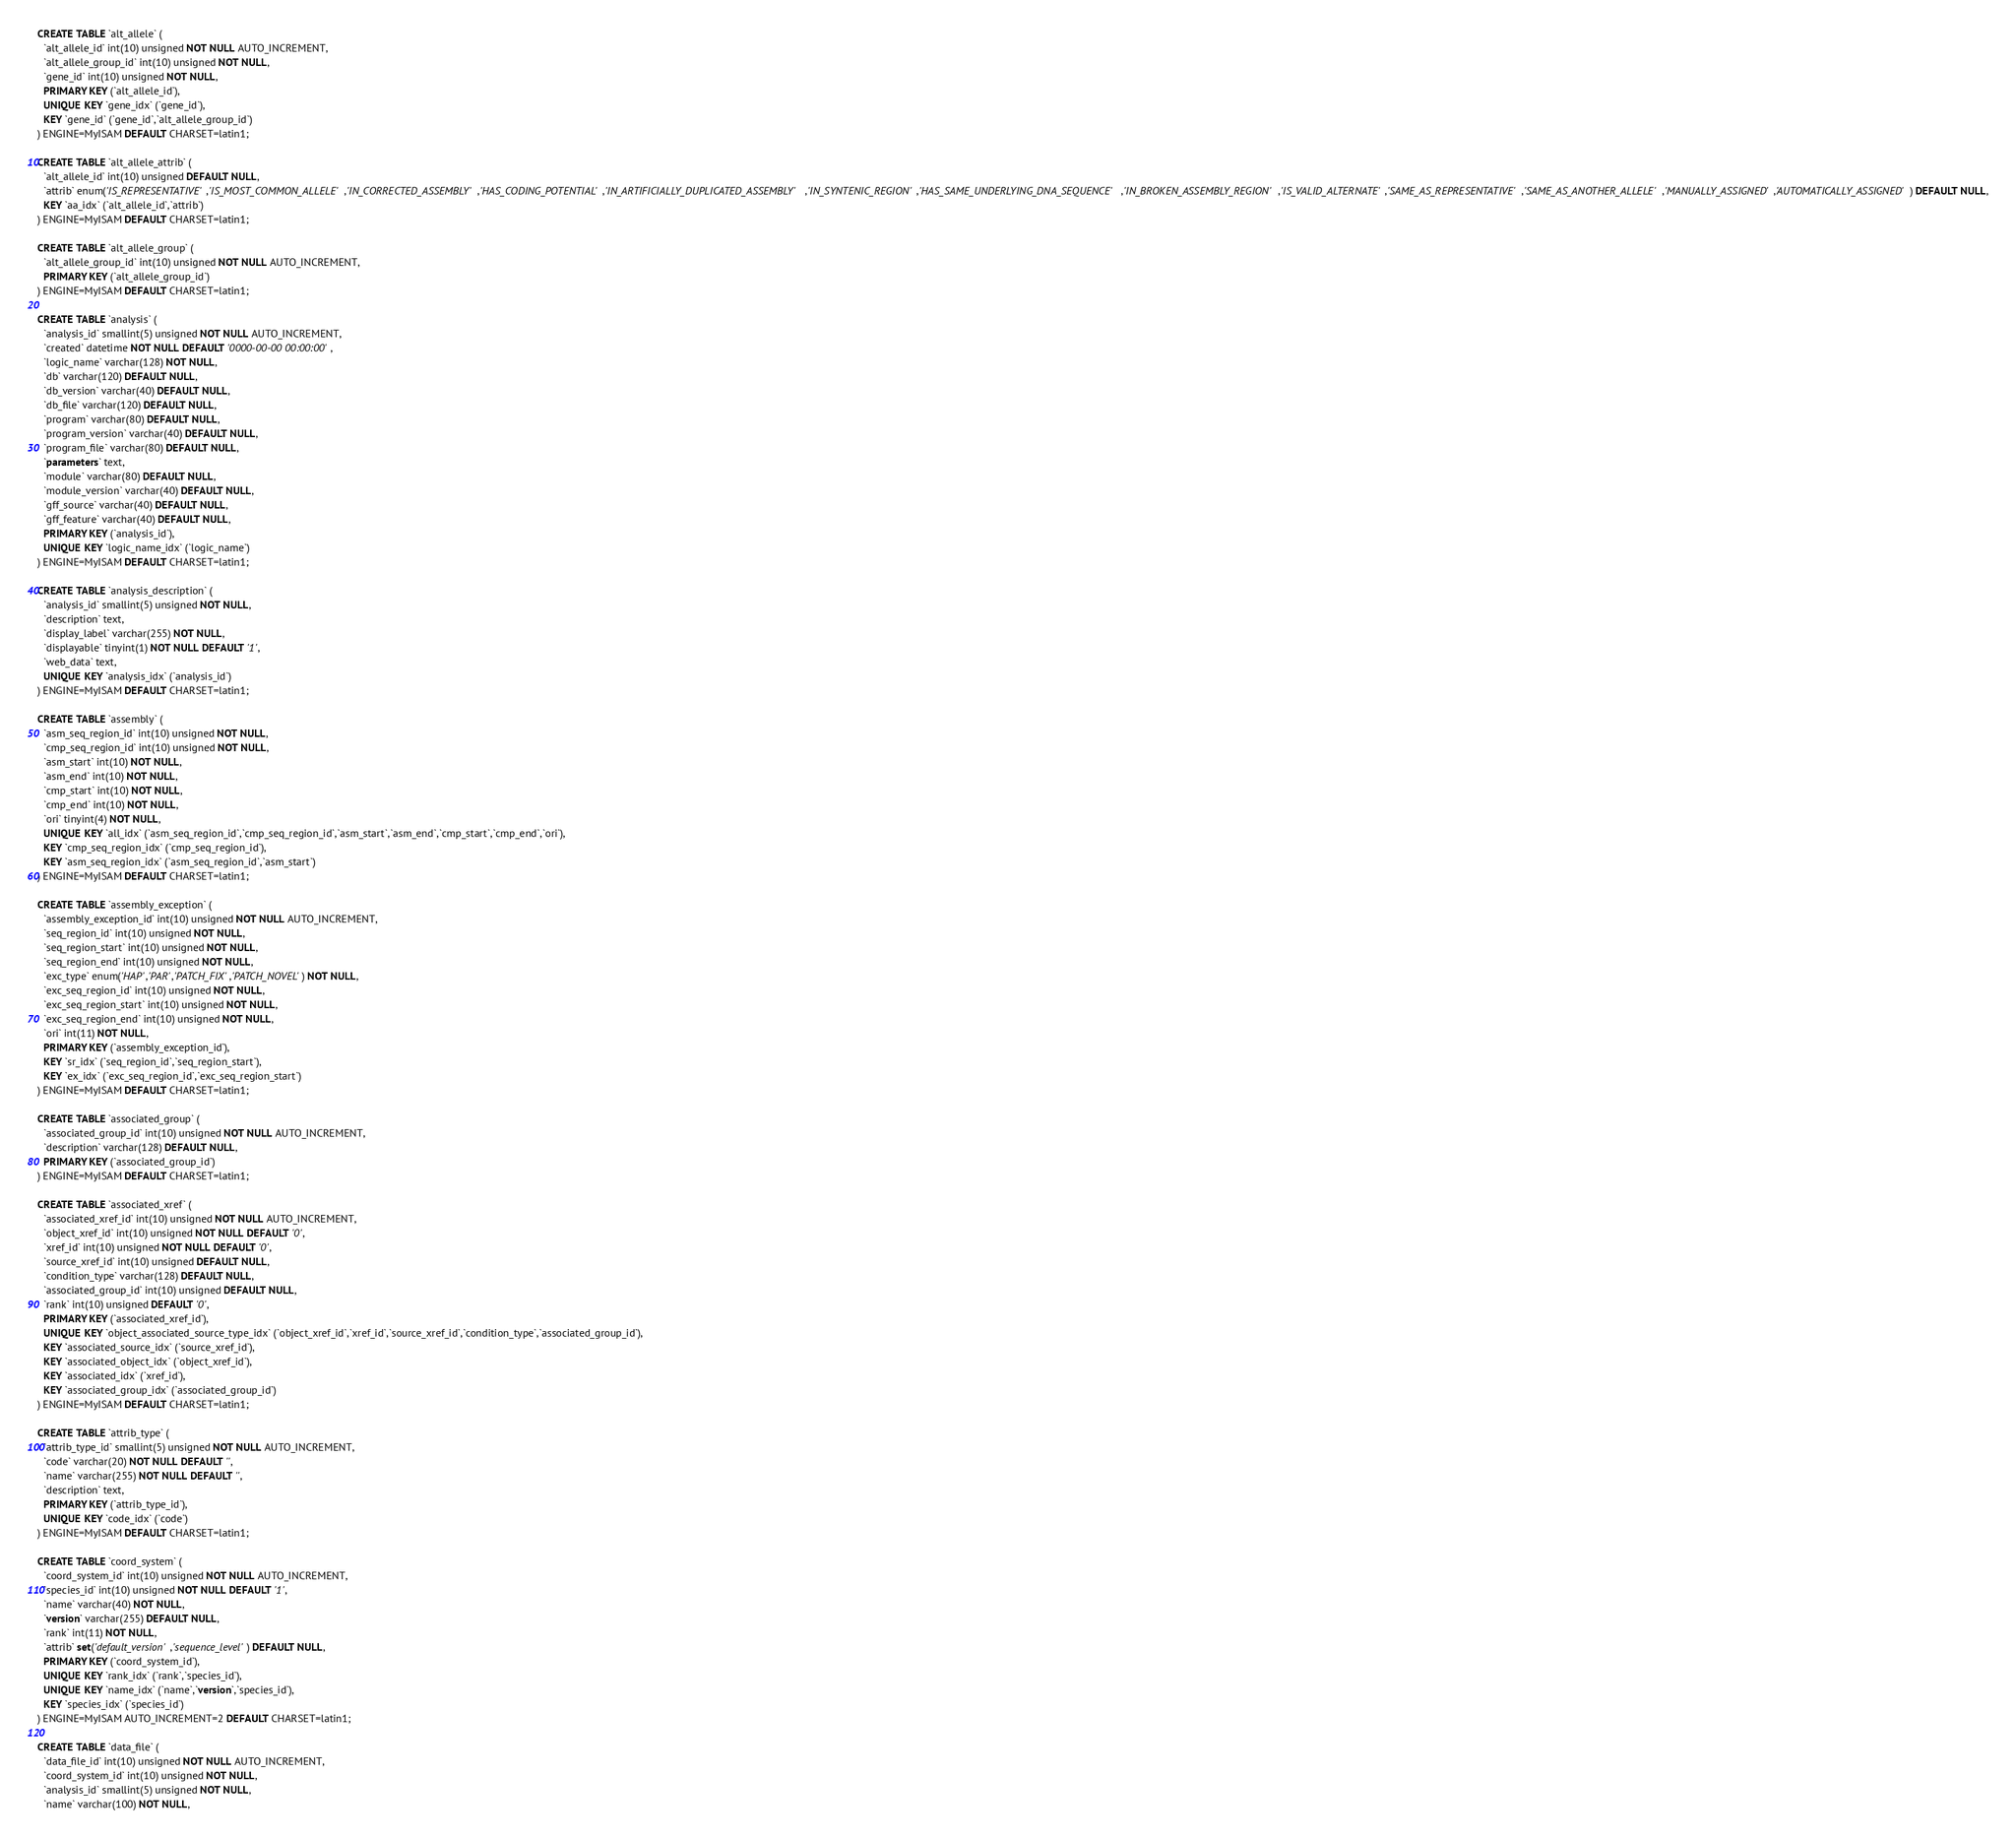<code> <loc_0><loc_0><loc_500><loc_500><_SQL_>CREATE TABLE `alt_allele` (
  `alt_allele_id` int(10) unsigned NOT NULL AUTO_INCREMENT,
  `alt_allele_group_id` int(10) unsigned NOT NULL,
  `gene_id` int(10) unsigned NOT NULL,
  PRIMARY KEY (`alt_allele_id`),
  UNIQUE KEY `gene_idx` (`gene_id`),
  KEY `gene_id` (`gene_id`,`alt_allele_group_id`)
) ENGINE=MyISAM DEFAULT CHARSET=latin1;

CREATE TABLE `alt_allele_attrib` (
  `alt_allele_id` int(10) unsigned DEFAULT NULL,
  `attrib` enum('IS_REPRESENTATIVE','IS_MOST_COMMON_ALLELE','IN_CORRECTED_ASSEMBLY','HAS_CODING_POTENTIAL','IN_ARTIFICIALLY_DUPLICATED_ASSEMBLY','IN_SYNTENIC_REGION','HAS_SAME_UNDERLYING_DNA_SEQUENCE','IN_BROKEN_ASSEMBLY_REGION','IS_VALID_ALTERNATE','SAME_AS_REPRESENTATIVE','SAME_AS_ANOTHER_ALLELE','MANUALLY_ASSIGNED','AUTOMATICALLY_ASSIGNED') DEFAULT NULL,
  KEY `aa_idx` (`alt_allele_id`,`attrib`)
) ENGINE=MyISAM DEFAULT CHARSET=latin1;

CREATE TABLE `alt_allele_group` (
  `alt_allele_group_id` int(10) unsigned NOT NULL AUTO_INCREMENT,
  PRIMARY KEY (`alt_allele_group_id`)
) ENGINE=MyISAM DEFAULT CHARSET=latin1;

CREATE TABLE `analysis` (
  `analysis_id` smallint(5) unsigned NOT NULL AUTO_INCREMENT,
  `created` datetime NOT NULL DEFAULT '0000-00-00 00:00:00',
  `logic_name` varchar(128) NOT NULL,
  `db` varchar(120) DEFAULT NULL,
  `db_version` varchar(40) DEFAULT NULL,
  `db_file` varchar(120) DEFAULT NULL,
  `program` varchar(80) DEFAULT NULL,
  `program_version` varchar(40) DEFAULT NULL,
  `program_file` varchar(80) DEFAULT NULL,
  `parameters` text,
  `module` varchar(80) DEFAULT NULL,
  `module_version` varchar(40) DEFAULT NULL,
  `gff_source` varchar(40) DEFAULT NULL,
  `gff_feature` varchar(40) DEFAULT NULL,
  PRIMARY KEY (`analysis_id`),
  UNIQUE KEY `logic_name_idx` (`logic_name`)
) ENGINE=MyISAM DEFAULT CHARSET=latin1;

CREATE TABLE `analysis_description` (
  `analysis_id` smallint(5) unsigned NOT NULL,
  `description` text,
  `display_label` varchar(255) NOT NULL,
  `displayable` tinyint(1) NOT NULL DEFAULT '1',
  `web_data` text,
  UNIQUE KEY `analysis_idx` (`analysis_id`)
) ENGINE=MyISAM DEFAULT CHARSET=latin1;

CREATE TABLE `assembly` (
  `asm_seq_region_id` int(10) unsigned NOT NULL,
  `cmp_seq_region_id` int(10) unsigned NOT NULL,
  `asm_start` int(10) NOT NULL,
  `asm_end` int(10) NOT NULL,
  `cmp_start` int(10) NOT NULL,
  `cmp_end` int(10) NOT NULL,
  `ori` tinyint(4) NOT NULL,
  UNIQUE KEY `all_idx` (`asm_seq_region_id`,`cmp_seq_region_id`,`asm_start`,`asm_end`,`cmp_start`,`cmp_end`,`ori`),
  KEY `cmp_seq_region_idx` (`cmp_seq_region_id`),
  KEY `asm_seq_region_idx` (`asm_seq_region_id`,`asm_start`)
) ENGINE=MyISAM DEFAULT CHARSET=latin1;

CREATE TABLE `assembly_exception` (
  `assembly_exception_id` int(10) unsigned NOT NULL AUTO_INCREMENT,
  `seq_region_id` int(10) unsigned NOT NULL,
  `seq_region_start` int(10) unsigned NOT NULL,
  `seq_region_end` int(10) unsigned NOT NULL,
  `exc_type` enum('HAP','PAR','PATCH_FIX','PATCH_NOVEL') NOT NULL,
  `exc_seq_region_id` int(10) unsigned NOT NULL,
  `exc_seq_region_start` int(10) unsigned NOT NULL,
  `exc_seq_region_end` int(10) unsigned NOT NULL,
  `ori` int(11) NOT NULL,
  PRIMARY KEY (`assembly_exception_id`),
  KEY `sr_idx` (`seq_region_id`,`seq_region_start`),
  KEY `ex_idx` (`exc_seq_region_id`,`exc_seq_region_start`)
) ENGINE=MyISAM DEFAULT CHARSET=latin1;

CREATE TABLE `associated_group` (
  `associated_group_id` int(10) unsigned NOT NULL AUTO_INCREMENT,
  `description` varchar(128) DEFAULT NULL,
  PRIMARY KEY (`associated_group_id`)
) ENGINE=MyISAM DEFAULT CHARSET=latin1;

CREATE TABLE `associated_xref` (
  `associated_xref_id` int(10) unsigned NOT NULL AUTO_INCREMENT,
  `object_xref_id` int(10) unsigned NOT NULL DEFAULT '0',
  `xref_id` int(10) unsigned NOT NULL DEFAULT '0',
  `source_xref_id` int(10) unsigned DEFAULT NULL,
  `condition_type` varchar(128) DEFAULT NULL,
  `associated_group_id` int(10) unsigned DEFAULT NULL,
  `rank` int(10) unsigned DEFAULT '0',
  PRIMARY KEY (`associated_xref_id`),
  UNIQUE KEY `object_associated_source_type_idx` (`object_xref_id`,`xref_id`,`source_xref_id`,`condition_type`,`associated_group_id`),
  KEY `associated_source_idx` (`source_xref_id`),
  KEY `associated_object_idx` (`object_xref_id`),
  KEY `associated_idx` (`xref_id`),
  KEY `associated_group_idx` (`associated_group_id`)
) ENGINE=MyISAM DEFAULT CHARSET=latin1;

CREATE TABLE `attrib_type` (
  `attrib_type_id` smallint(5) unsigned NOT NULL AUTO_INCREMENT,
  `code` varchar(20) NOT NULL DEFAULT '',
  `name` varchar(255) NOT NULL DEFAULT '',
  `description` text,
  PRIMARY KEY (`attrib_type_id`),
  UNIQUE KEY `code_idx` (`code`)
) ENGINE=MyISAM DEFAULT CHARSET=latin1;

CREATE TABLE `coord_system` (
  `coord_system_id` int(10) unsigned NOT NULL AUTO_INCREMENT,
  `species_id` int(10) unsigned NOT NULL DEFAULT '1',
  `name` varchar(40) NOT NULL,
  `version` varchar(255) DEFAULT NULL,
  `rank` int(11) NOT NULL,
  `attrib` set('default_version','sequence_level') DEFAULT NULL,
  PRIMARY KEY (`coord_system_id`),
  UNIQUE KEY `rank_idx` (`rank`,`species_id`),
  UNIQUE KEY `name_idx` (`name`,`version`,`species_id`),
  KEY `species_idx` (`species_id`)
) ENGINE=MyISAM AUTO_INCREMENT=2 DEFAULT CHARSET=latin1;

CREATE TABLE `data_file` (
  `data_file_id` int(10) unsigned NOT NULL AUTO_INCREMENT,
  `coord_system_id` int(10) unsigned NOT NULL,
  `analysis_id` smallint(5) unsigned NOT NULL,
  `name` varchar(100) NOT NULL,</code> 